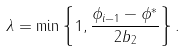<formula> <loc_0><loc_0><loc_500><loc_500>\lambda = \min \left \{ 1 , \frac { \phi _ { i - 1 } - \phi ^ { * } } { 2 b _ { 2 } } \right \} .</formula> 